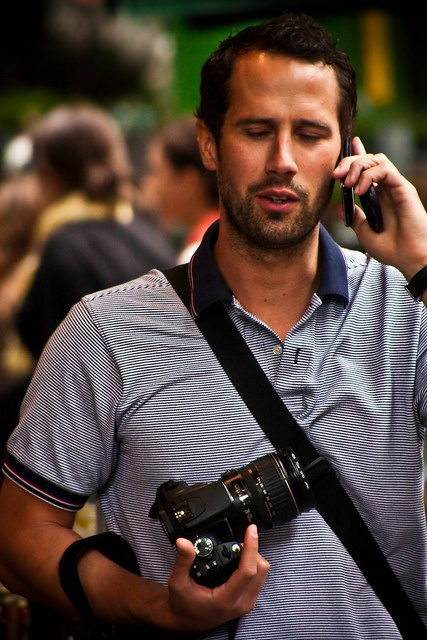Describe the objects in this image and their specific colors. I can see people in black, maroon, gray, and lavender tones, people in black, maroon, and gray tones, people in black, darkgreen, and gray tones, people in black, maroon, and brown tones, and cell phone in black, maroon, lightgray, and brown tones in this image. 